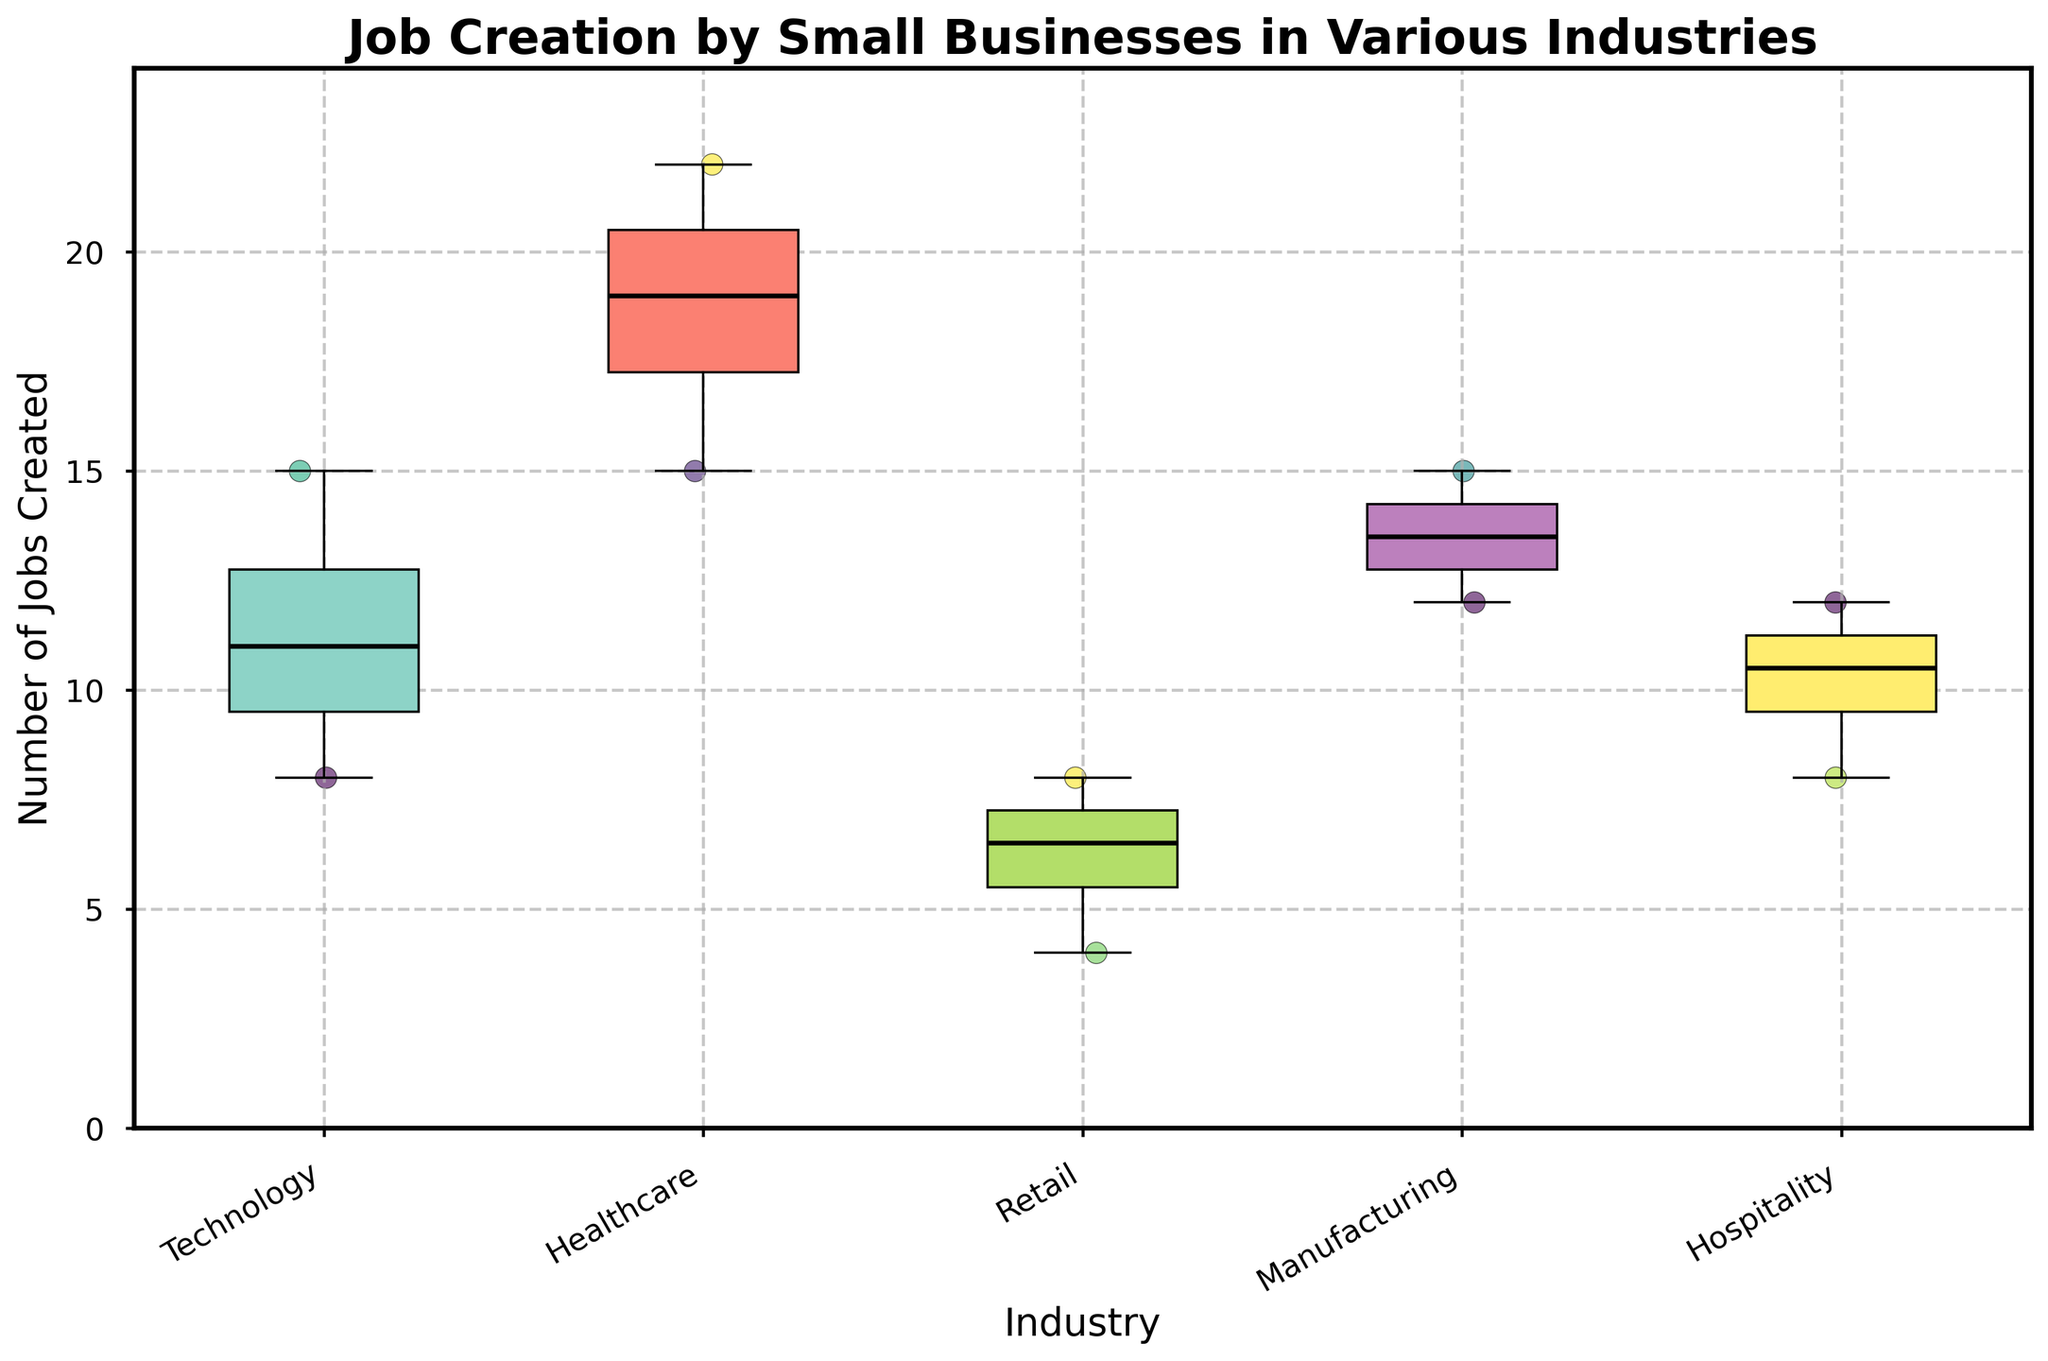What is the title of the plot? The title is displayed at the top of the figure, indicating what the plot is about.
Answer: Job Creation by Small Businesses in Various Industries Which industry has the highest median number of jobs created? The median is represented by the thick black line inside each box. Look for the highest black line among all industries.
Answer: Healthcare How many industries are represented in the plot? The number of unique labels on the x-axis indicates the number of industries.
Answer: 5 What is the interquartile range (IQR) of jobs created in the Technology industry? The IQR is the range between the first quartile (bottom of the box) and the third quartile (top of the box) of the Technology industry.
Answer: 4 (from approximately 8 to 12) Which industry has the lowest minimum number of jobs created and what is that value? The minimum value is shown as the lowest point of the whisker or the points below the whisker. Look for the lowest such point and identify the corresponding industry and value.
Answer: Retail, 4 What is the median number of jobs created in the Manufacturing industry? The black line inside the box for the Manufacturing industry indicates the median.
Answer: 13.5 Compare the variability in job creation between the Retail and Manufacturing industries. Which one has more variability? Variability can be inferred from the size of the interquartile range and the range between the whiskers. Compare these between Retail and Manufacturing.
Answer: Retail Which industry shows the most outliers, and how can you tell? Outliers are typically displayed as points outside the whiskers. Identify the industry with the most such points.
Answer: Technology In the Healthcare industry, what is the range of the middle 50% of data points? The range of the middle 50% is given by the interquartile range (IQR), which is the distance between the first and third quartiles (edges of the box).
Answer: 7 (from approximately 15 to 22) Are there any industries where all the data points lie within the box (i.e., no points outside the whiskers)? If so, name them. Observing if any industry on the plot has all individual data points within the whiskers, without any outliers.
Answer: Technology, Healthcare, Manufacturing 